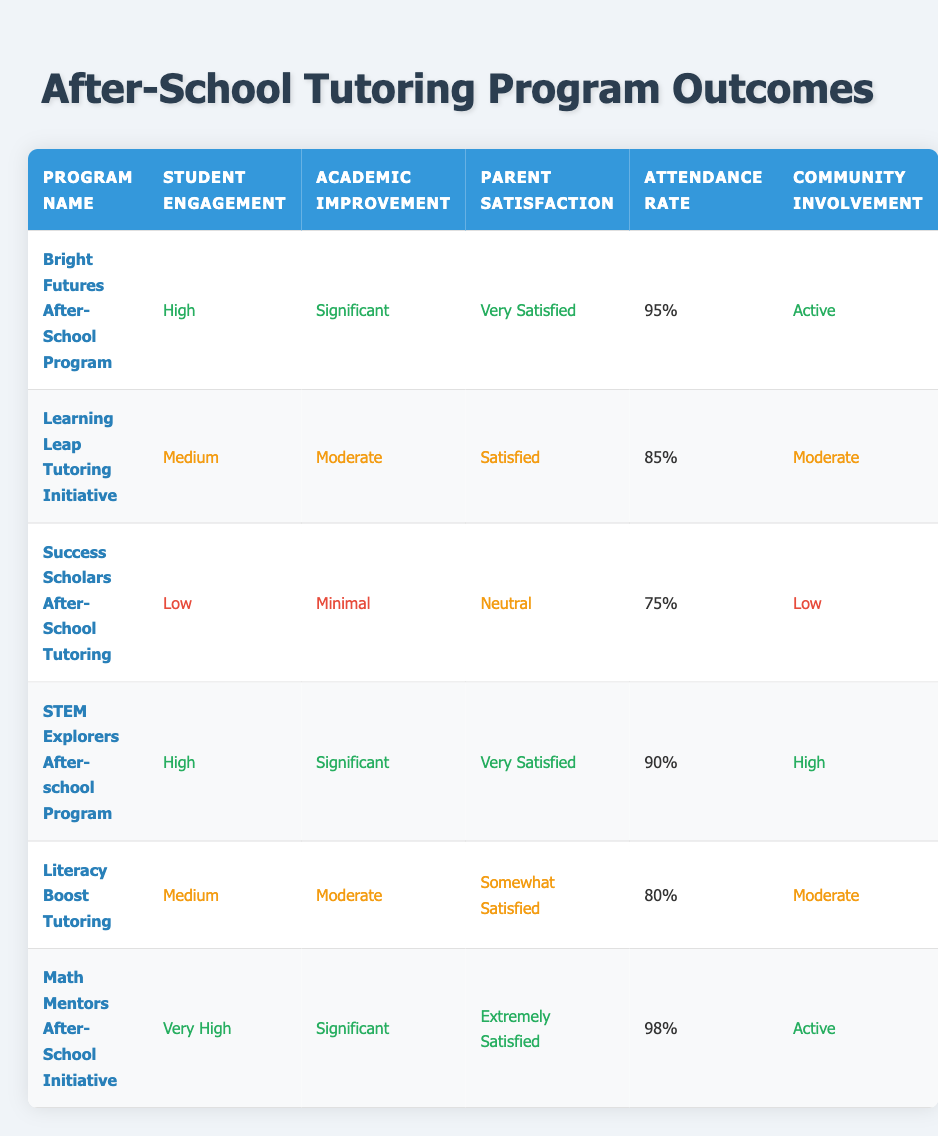What is the attendance rate for Math Mentors After-School Initiative? The table lists the attendance rates for all programs. For Math Mentors After-School Initiative, it explicitly shows an attendance rate of 98%.
Answer: 98% Which program has the highest academic improvement? Looking at the academic improvement column, both the Bright Futures After-School Program and Math Mentors After-School Initiative indicate "Significant" improvement. There are no programs rated higher than that.
Answer: Bright Futures After-School Program and Math Mentors After-School Initiative Is the parent satisfaction level in Literacy Boost Tutoring "Very Satisfied"? The table clearly states the parent satisfaction level for Literacy Boost Tutoring as "Somewhat Satisfied", indicating that it is not "Very Satisfied".
Answer: No What is the average attendance rate of all programs? To find the average, we need to convert the attendance rates to numerical values: 95, 85, 75, 90, 80, and 98. Adding these gives 95 + 85 + 75 + 90 + 80 + 98 = 523. There are 6 programs, so the average is 523 / 6 = 87.17%.
Answer: 87.17% Are there more programs with high community involvement than with medium involvement? Examining the community involvement column, "Active" appears 3 times (Bright Futures, Math Mentors, and STEM Explorers), while "Moderate" appears 2 times (Learning Leap and Literacy Boost). Since there are more programs with high involvement, the answer is yes.
Answer: Yes Which program has both high student engagement and high parent satisfaction? From the table, the programs with high student engagement: Bright Futures, STEM Explorers, and Math Mentors. The parent satisfaction for these is: Very Satisfied (Bright Futures and STEM) and Extremely Satisfied (Math Mentors), all indicate high satisfaction.
Answer: Bright Futures After-School Program, STEM Explorers After-school Program, Math Mentors After-School Initiative What is the lowest attendance rate among the programs listed? The attendance rates are 95%, 85%, 75%, 90%, 80%, and 98%. The lowest value among these is 75%, which corresponds to the Success Scholars After-School Tutoring.
Answer: 75% Is the student engagement for STEM Explorers After-school Program classified as "Very High"? According to the table, the student engagement for STEM Explorers is marked as "High" and not "Very High".
Answer: No How many programs are classified with "Medium" academic improvement? By reviewing the academic improvement column, only two programs (Learning Leap Tutoring Initiative and Literacy Boost Tutoring) fall under the "Moderate" category.
Answer: 2 